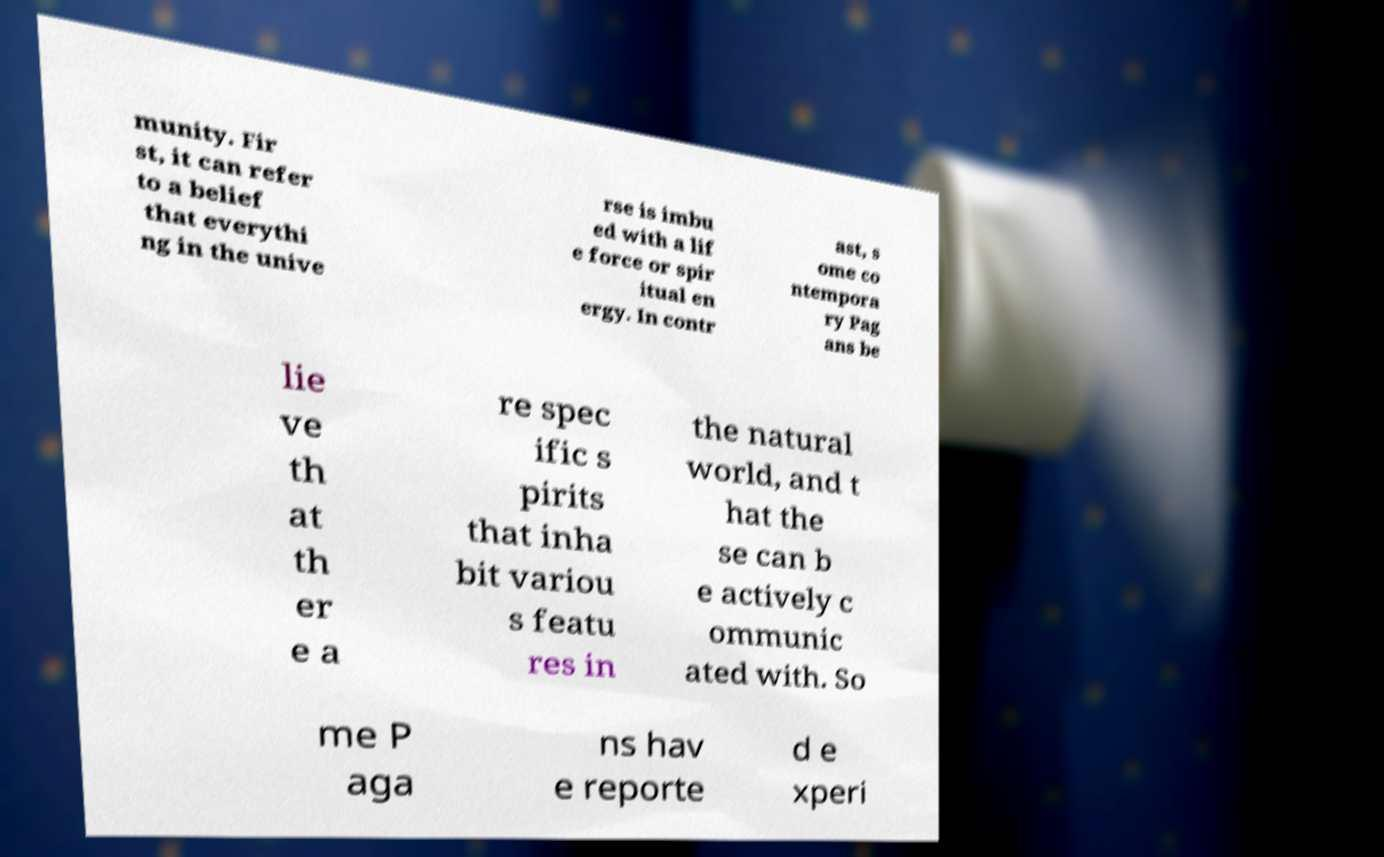Can you accurately transcribe the text from the provided image for me? munity. Fir st, it can refer to a belief that everythi ng in the unive rse is imbu ed with a lif e force or spir itual en ergy. In contr ast, s ome co ntempora ry Pag ans be lie ve th at th er e a re spec ific s pirits that inha bit variou s featu res in the natural world, and t hat the se can b e actively c ommunic ated with. So me P aga ns hav e reporte d e xperi 